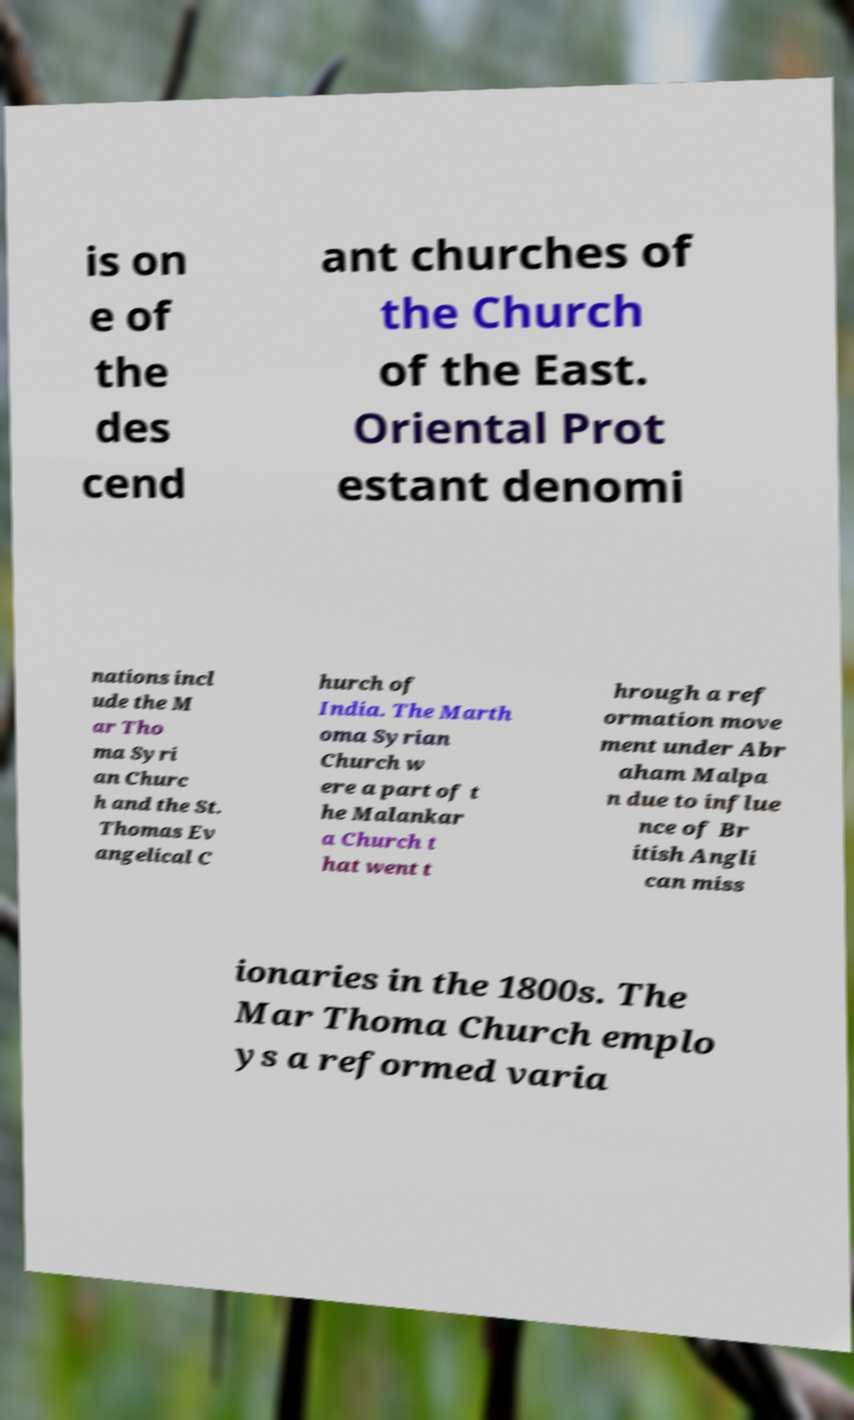Can you read and provide the text displayed in the image?This photo seems to have some interesting text. Can you extract and type it out for me? is on e of the des cend ant churches of the Church of the East. Oriental Prot estant denomi nations incl ude the M ar Tho ma Syri an Churc h and the St. Thomas Ev angelical C hurch of India. The Marth oma Syrian Church w ere a part of t he Malankar a Church t hat went t hrough a ref ormation move ment under Abr aham Malpa n due to influe nce of Br itish Angli can miss ionaries in the 1800s. The Mar Thoma Church emplo ys a reformed varia 